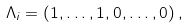Convert formula to latex. <formula><loc_0><loc_0><loc_500><loc_500>\Lambda _ { i } = \left ( 1 , \dots , 1 , 0 , \dots , 0 \right ) ,</formula> 